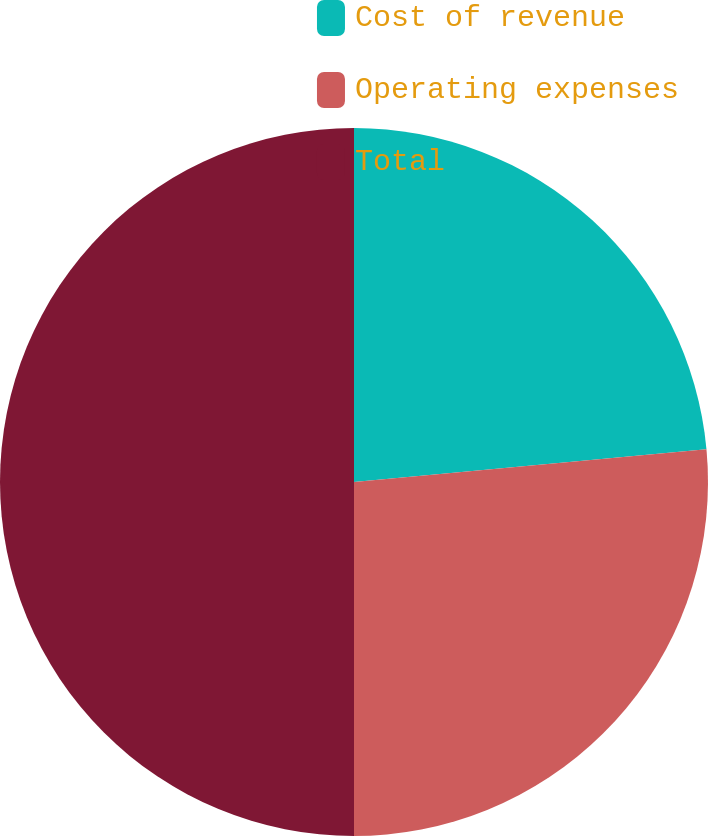Convert chart. <chart><loc_0><loc_0><loc_500><loc_500><pie_chart><fcel>Cost of revenue<fcel>Operating expenses<fcel>Total<nl><fcel>23.52%<fcel>26.48%<fcel>50.0%<nl></chart> 